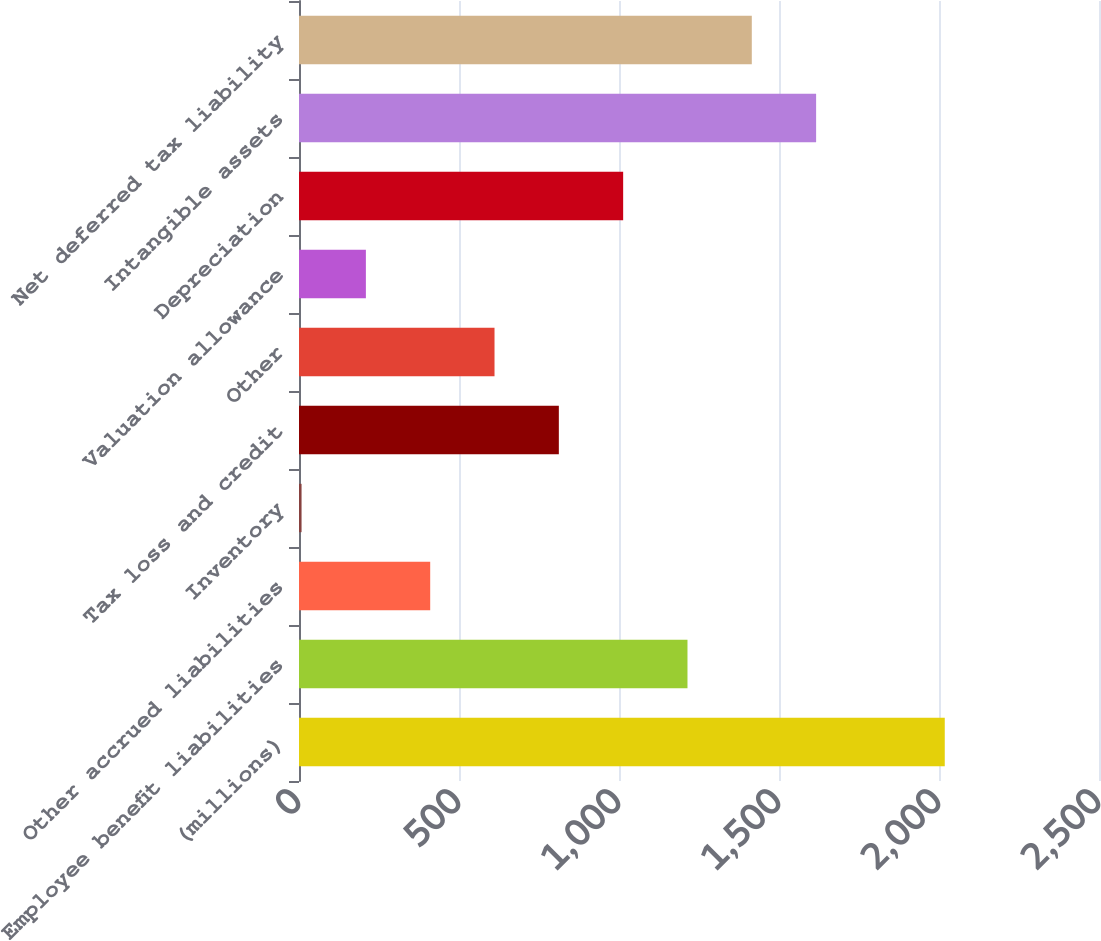Convert chart. <chart><loc_0><loc_0><loc_500><loc_500><bar_chart><fcel>(millions)<fcel>Employee benefit liabilities<fcel>Other accrued liabilities<fcel>Inventory<fcel>Tax loss and credit<fcel>Other<fcel>Valuation allowance<fcel>Depreciation<fcel>Intangible assets<fcel>Net deferred tax liability<nl><fcel>2018<fcel>1214<fcel>410<fcel>8<fcel>812<fcel>611<fcel>209<fcel>1013<fcel>1616<fcel>1415<nl></chart> 